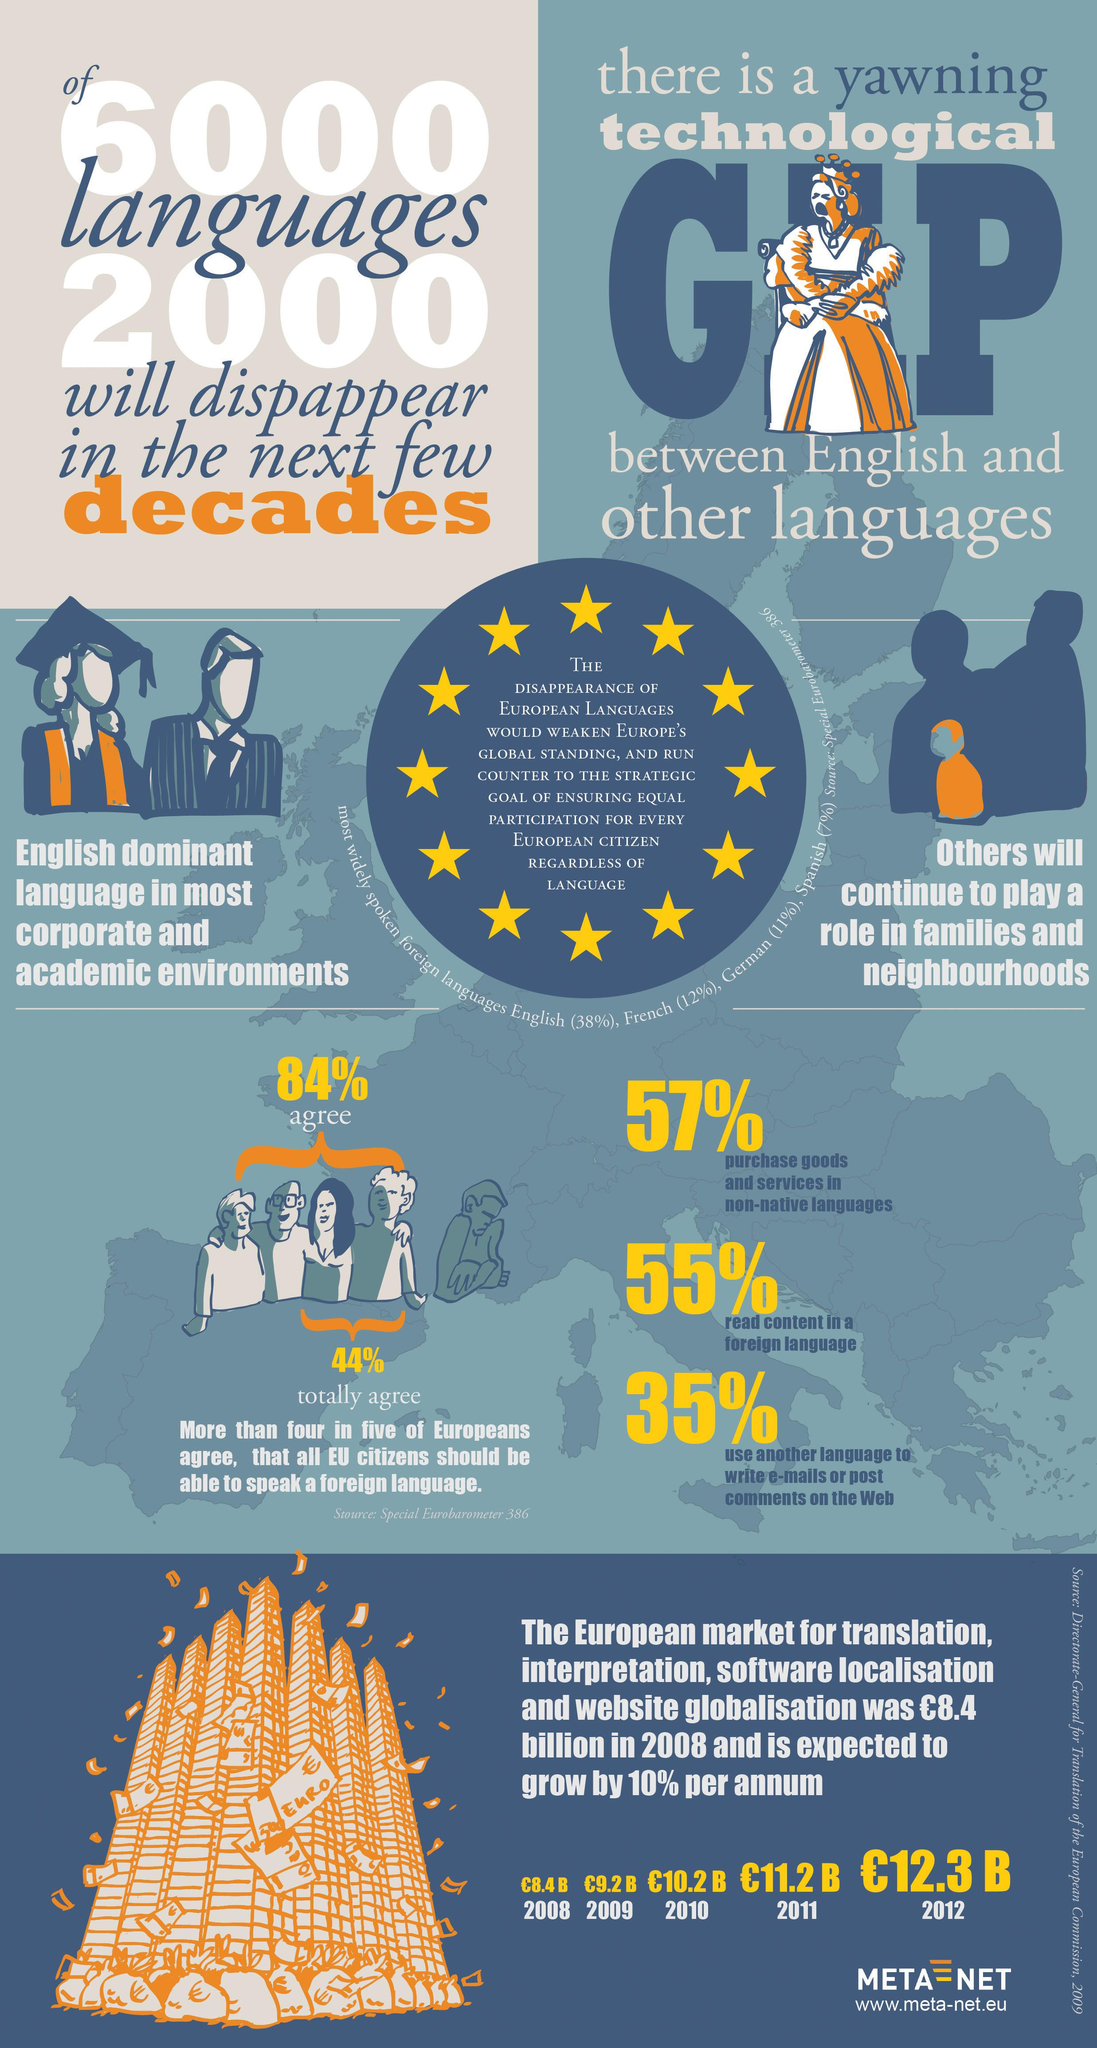Draw attention to some important aspects in this diagram. French is the second most widely spoken foreign language in Europe. In 2010, the European market for translation, interpretation, software localization, and website localization was valued at 10.2 billion Euros. In 2012, the European market for translation, interpretation, software localization, and website localization was valued at 12.3 billion Euros. German is the third most widely spoken foreign language in Europe. In 2011, the European market for translation, interpretation, software localization, and website localization was valued at approximately 11.2 billion Euros. 